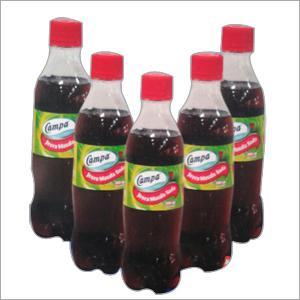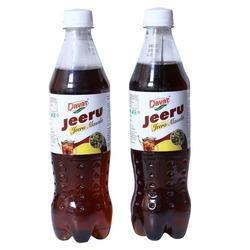The first image is the image on the left, the second image is the image on the right. Examine the images to the left and right. Is the description "One image shows five upright identical bottles arranged in a V-formation." accurate? Answer yes or no. Yes. The first image is the image on the left, the second image is the image on the right. Evaluate the accuracy of this statement regarding the images: "There are at least seven bottles in total.". Is it true? Answer yes or no. Yes. 